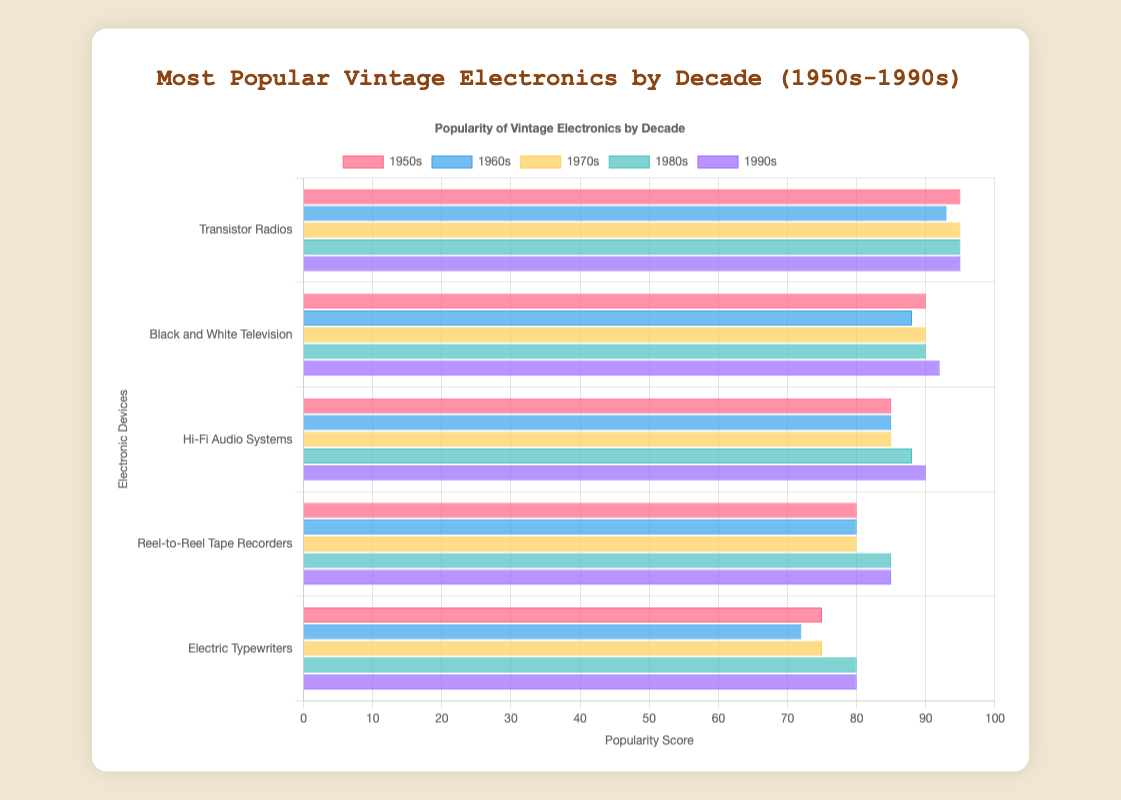What is the most popular electronic device in the 1980s based on the chart? The 1980s data shows that Personal Computers have the highest popularity score of 95.
Answer: Personal Computers What is the difference in popularity scores between Cassette Tape Players and VCRs in the 1970s? The popularity score of Cassette Tape Players is 95, and VCRs is 90. The difference is 95 - 90.
Answer: 5 Which decade has the highest popularity score for the top electronic device? Comparing the top scores across decades: 1950s (Transistor Radios 95), 1960s (Color Television 93), 1970s (Cassette Tape Players 95), 1980s (Personal Computers 95), 1990s (Mobile Phones 95). All except the 1960s have a top score of 95.
Answer: 1950s, 1970s, 1980s, 1990s Does any device have a popularity score of exactly 88 in different decades? The 1960s have 8-Track Tape Players, and the 1980s have Nintendo Entertainment System (NES), both scoring 88.
Answer: Yes What is the average popularity score of the top five electronics in the 1990s? The scores are Mobile Phones (95), DVD Players (92), PlayStation (90), Digital Cameras (85), and MP3 Players (80). The sum is 95 + 92 + 90 + 85 + 80 = 442. The average is 442 / 5.
Answer: 88.4 Which decade features a blue-colored bar for its electronics? The second dataset, which is associated with the 1960s, typically would have a blue color based on the color sequence provided.
Answer: 1960s What is the combined popularity score of Personal Computers and Walkman Cassette Players in the 1980s? The popularity score of Personal Computers is 95, and Walkman Cassette Players is 90. The combined score is 95 + 90.
Answer: 185 How many electronic devices have a popularity score of 85 across all decades? From the chart data: Hi-Fi Audio Systems (1950s), Portable Transistor Radios (1960s), Atari 2600 (1970s), Compact Disc Players (1980s), Digital Cameras (1990s). There are five such devices.
Answer: 5 Which electronic device has the lowest popularity score among all decades? The lowest popularity scores from the data are Electric Toothbrushes (1960s) with 72.
Answer: Electric Toothbrushes Is there a decade where all top electronic devices have scores above 80? Observing the data: 1950s has all scores above 75, 1960s has one score below 80 (Electric Toothbrushes), 1970s has all above 75, 1980s has all above 80, 1990s has all above 80. Only the 1980s and 1990s fulfill the condition.
Answer: 1980s, 1990s 